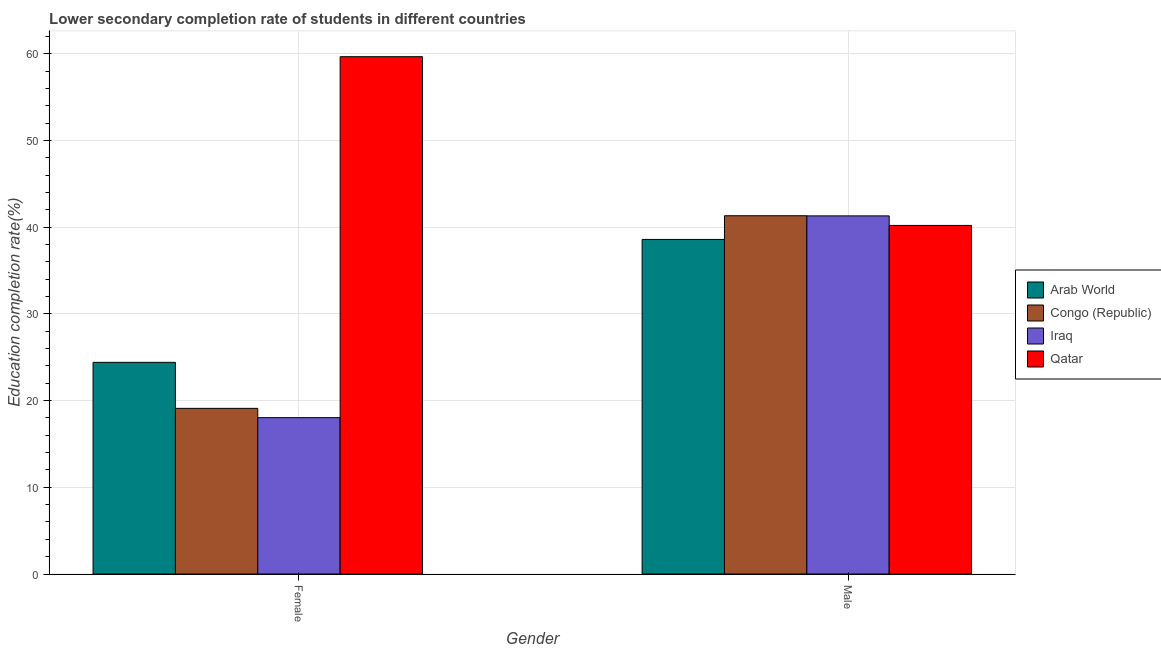How many groups of bars are there?
Ensure brevity in your answer.  2. Are the number of bars per tick equal to the number of legend labels?
Provide a succinct answer. Yes. What is the education completion rate of female students in Congo (Republic)?
Your response must be concise. 19.1. Across all countries, what is the maximum education completion rate of female students?
Offer a very short reply. 59.66. Across all countries, what is the minimum education completion rate of male students?
Provide a succinct answer. 38.59. In which country was the education completion rate of female students maximum?
Give a very brief answer. Qatar. In which country was the education completion rate of female students minimum?
Your response must be concise. Iraq. What is the total education completion rate of male students in the graph?
Provide a short and direct response. 161.41. What is the difference between the education completion rate of female students in Qatar and that in Iraq?
Make the answer very short. 41.63. What is the difference between the education completion rate of female students in Arab World and the education completion rate of male students in Qatar?
Your answer should be very brief. -15.79. What is the average education completion rate of male students per country?
Provide a short and direct response. 40.35. What is the difference between the education completion rate of female students and education completion rate of male students in Iraq?
Your response must be concise. -23.27. In how many countries, is the education completion rate of male students greater than 4 %?
Make the answer very short. 4. What is the ratio of the education completion rate of female students in Congo (Republic) to that in Qatar?
Ensure brevity in your answer.  0.32. In how many countries, is the education completion rate of female students greater than the average education completion rate of female students taken over all countries?
Offer a terse response. 1. What does the 4th bar from the left in Female represents?
Provide a short and direct response. Qatar. What does the 1st bar from the right in Female represents?
Make the answer very short. Qatar. How many bars are there?
Give a very brief answer. 8. Are all the bars in the graph horizontal?
Your answer should be very brief. No. Are the values on the major ticks of Y-axis written in scientific E-notation?
Your answer should be compact. No. Where does the legend appear in the graph?
Your response must be concise. Center right. What is the title of the graph?
Make the answer very short. Lower secondary completion rate of students in different countries. Does "Sudan" appear as one of the legend labels in the graph?
Provide a succinct answer. No. What is the label or title of the Y-axis?
Offer a very short reply. Education completion rate(%). What is the Education completion rate(%) of Arab World in Female?
Offer a very short reply. 24.41. What is the Education completion rate(%) of Congo (Republic) in Female?
Provide a succinct answer. 19.1. What is the Education completion rate(%) in Iraq in Female?
Your answer should be compact. 18.03. What is the Education completion rate(%) of Qatar in Female?
Give a very brief answer. 59.66. What is the Education completion rate(%) of Arab World in Male?
Provide a succinct answer. 38.59. What is the Education completion rate(%) in Congo (Republic) in Male?
Offer a very short reply. 41.32. What is the Education completion rate(%) of Iraq in Male?
Make the answer very short. 41.3. What is the Education completion rate(%) in Qatar in Male?
Offer a terse response. 40.2. Across all Gender, what is the maximum Education completion rate(%) in Arab World?
Make the answer very short. 38.59. Across all Gender, what is the maximum Education completion rate(%) in Congo (Republic)?
Keep it short and to the point. 41.32. Across all Gender, what is the maximum Education completion rate(%) in Iraq?
Ensure brevity in your answer.  41.3. Across all Gender, what is the maximum Education completion rate(%) in Qatar?
Your answer should be compact. 59.66. Across all Gender, what is the minimum Education completion rate(%) in Arab World?
Offer a terse response. 24.41. Across all Gender, what is the minimum Education completion rate(%) in Congo (Republic)?
Offer a very short reply. 19.1. Across all Gender, what is the minimum Education completion rate(%) in Iraq?
Provide a succinct answer. 18.03. Across all Gender, what is the minimum Education completion rate(%) in Qatar?
Offer a very short reply. 40.2. What is the total Education completion rate(%) of Arab World in the graph?
Keep it short and to the point. 63. What is the total Education completion rate(%) in Congo (Republic) in the graph?
Your answer should be very brief. 60.42. What is the total Education completion rate(%) of Iraq in the graph?
Your response must be concise. 59.33. What is the total Education completion rate(%) of Qatar in the graph?
Your response must be concise. 99.86. What is the difference between the Education completion rate(%) of Arab World in Female and that in Male?
Offer a terse response. -14.18. What is the difference between the Education completion rate(%) of Congo (Republic) in Female and that in Male?
Make the answer very short. -22.22. What is the difference between the Education completion rate(%) of Iraq in Female and that in Male?
Give a very brief answer. -23.27. What is the difference between the Education completion rate(%) of Qatar in Female and that in Male?
Your response must be concise. 19.46. What is the difference between the Education completion rate(%) in Arab World in Female and the Education completion rate(%) in Congo (Republic) in Male?
Your answer should be very brief. -16.91. What is the difference between the Education completion rate(%) in Arab World in Female and the Education completion rate(%) in Iraq in Male?
Offer a terse response. -16.89. What is the difference between the Education completion rate(%) of Arab World in Female and the Education completion rate(%) of Qatar in Male?
Ensure brevity in your answer.  -15.79. What is the difference between the Education completion rate(%) of Congo (Republic) in Female and the Education completion rate(%) of Iraq in Male?
Provide a short and direct response. -22.2. What is the difference between the Education completion rate(%) in Congo (Republic) in Female and the Education completion rate(%) in Qatar in Male?
Give a very brief answer. -21.1. What is the difference between the Education completion rate(%) of Iraq in Female and the Education completion rate(%) of Qatar in Male?
Ensure brevity in your answer.  -22.17. What is the average Education completion rate(%) of Arab World per Gender?
Provide a short and direct response. 31.5. What is the average Education completion rate(%) of Congo (Republic) per Gender?
Provide a short and direct response. 30.21. What is the average Education completion rate(%) of Iraq per Gender?
Make the answer very short. 29.67. What is the average Education completion rate(%) of Qatar per Gender?
Ensure brevity in your answer.  49.93. What is the difference between the Education completion rate(%) of Arab World and Education completion rate(%) of Congo (Republic) in Female?
Your response must be concise. 5.31. What is the difference between the Education completion rate(%) in Arab World and Education completion rate(%) in Iraq in Female?
Give a very brief answer. 6.38. What is the difference between the Education completion rate(%) of Arab World and Education completion rate(%) of Qatar in Female?
Give a very brief answer. -35.25. What is the difference between the Education completion rate(%) in Congo (Republic) and Education completion rate(%) in Iraq in Female?
Keep it short and to the point. 1.07. What is the difference between the Education completion rate(%) of Congo (Republic) and Education completion rate(%) of Qatar in Female?
Keep it short and to the point. -40.56. What is the difference between the Education completion rate(%) of Iraq and Education completion rate(%) of Qatar in Female?
Provide a succinct answer. -41.63. What is the difference between the Education completion rate(%) of Arab World and Education completion rate(%) of Congo (Republic) in Male?
Offer a terse response. -2.73. What is the difference between the Education completion rate(%) of Arab World and Education completion rate(%) of Iraq in Male?
Your answer should be compact. -2.72. What is the difference between the Education completion rate(%) of Arab World and Education completion rate(%) of Qatar in Male?
Keep it short and to the point. -1.62. What is the difference between the Education completion rate(%) in Congo (Republic) and Education completion rate(%) in Iraq in Male?
Give a very brief answer. 0.02. What is the difference between the Education completion rate(%) of Congo (Republic) and Education completion rate(%) of Qatar in Male?
Offer a very short reply. 1.12. What is the ratio of the Education completion rate(%) of Arab World in Female to that in Male?
Your answer should be compact. 0.63. What is the ratio of the Education completion rate(%) in Congo (Republic) in Female to that in Male?
Keep it short and to the point. 0.46. What is the ratio of the Education completion rate(%) in Iraq in Female to that in Male?
Offer a terse response. 0.44. What is the ratio of the Education completion rate(%) in Qatar in Female to that in Male?
Your response must be concise. 1.48. What is the difference between the highest and the second highest Education completion rate(%) of Arab World?
Make the answer very short. 14.18. What is the difference between the highest and the second highest Education completion rate(%) of Congo (Republic)?
Your answer should be compact. 22.22. What is the difference between the highest and the second highest Education completion rate(%) in Iraq?
Ensure brevity in your answer.  23.27. What is the difference between the highest and the second highest Education completion rate(%) of Qatar?
Ensure brevity in your answer.  19.46. What is the difference between the highest and the lowest Education completion rate(%) in Arab World?
Ensure brevity in your answer.  14.18. What is the difference between the highest and the lowest Education completion rate(%) of Congo (Republic)?
Ensure brevity in your answer.  22.22. What is the difference between the highest and the lowest Education completion rate(%) in Iraq?
Offer a terse response. 23.27. What is the difference between the highest and the lowest Education completion rate(%) of Qatar?
Your answer should be very brief. 19.46. 